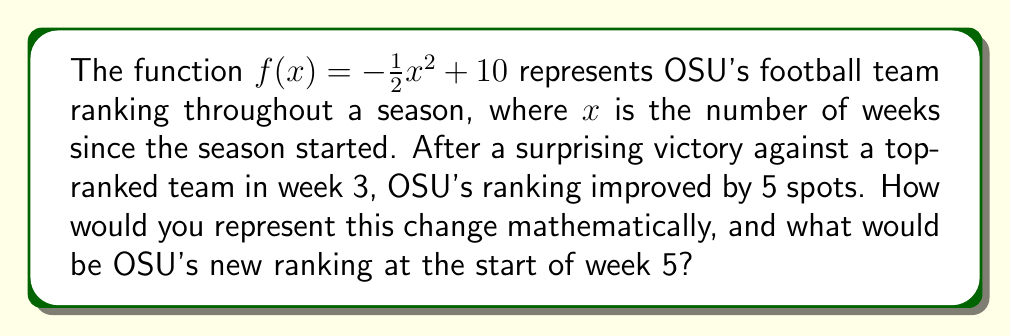What is the answer to this math problem? Let's approach this step-by-step:

1) The original function is $f(x) = -\frac{1}{2}x^2 + 10$

2) An improvement of 5 spots in the ranking means we need to shift the function up by 5 units. This is done by adding 5 to the function:

   $g(x) = f(x) + 5 = -\frac{1}{2}x^2 + 10 + 5 = -\frac{1}{2}x^2 + 15$

3) Now, we need to find OSU's ranking at the start of week 5. This means we need to evaluate $g(4)$, as week 5 starts after 4 weeks have passed:

   $g(4) = -\frac{1}{2}(4)^2 + 15$

4) Let's calculate this:
   $g(4) = -\frac{1}{2}(16) + 15 = -8 + 15 = 7$

Therefore, OSU's new ranking at the start of week 5 would be 7th place.
Answer: $g(x) = -\frac{1}{2}x^2 + 15$; 7th place 